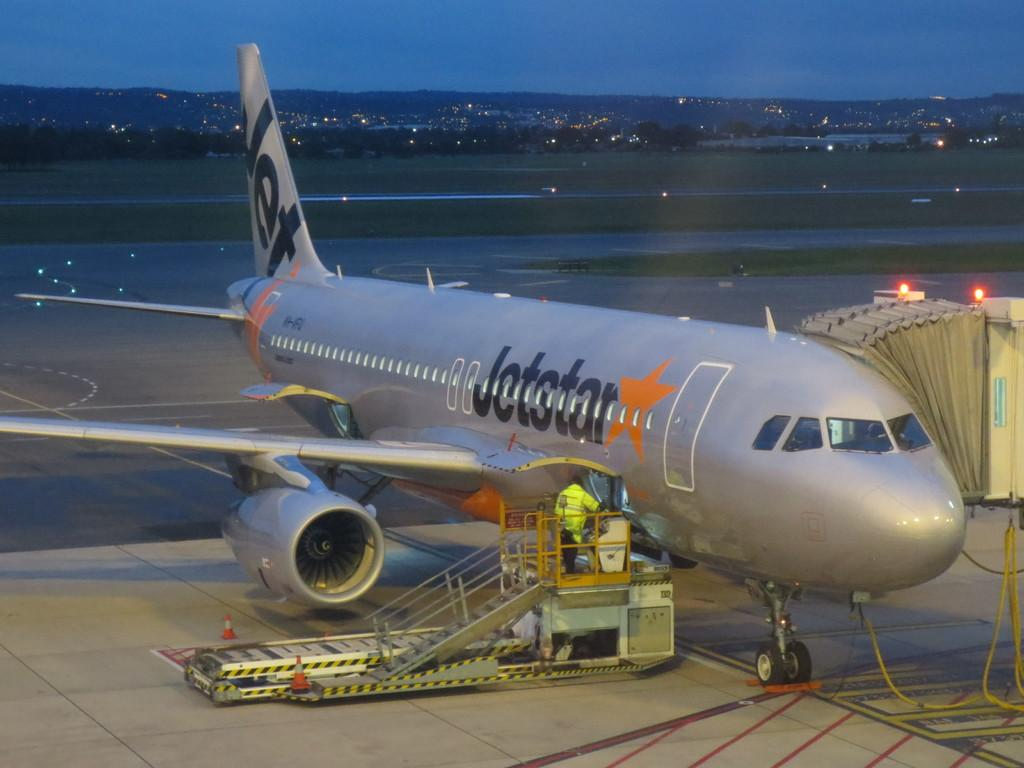What type of vehicle is in the image? There is a silver flight in the image. Where is the silver flight located? The silver flight is parked on the runway. What can be seen near the silver flight? There is a plane ramp with steps in the image. What is visible in the background of the image? There is a runway road, a green lawn, houses, lights, and mountains in the background of the image. What type of jelly can be seen on the silver flight in the image? There is no jelly present on the silver flight or in the image. How many ducks are visible on the runway in the image? There are no ducks visible on the runway or in the image. 